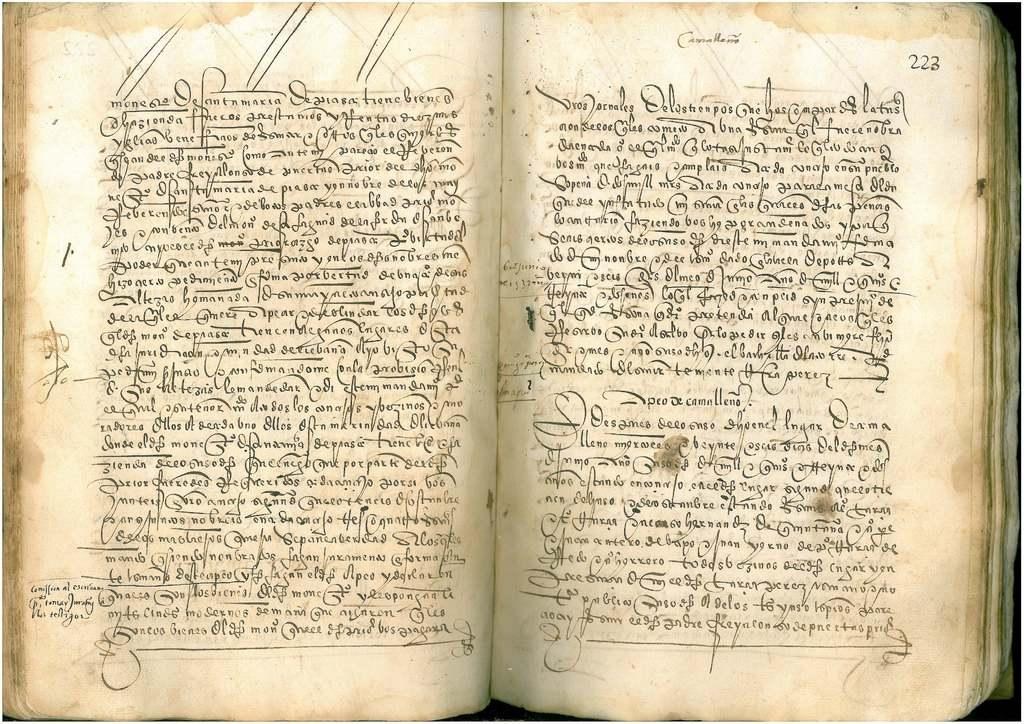Provide a one-sentence caption for the provided image. a book with the number for the page 223 at the top of it. 